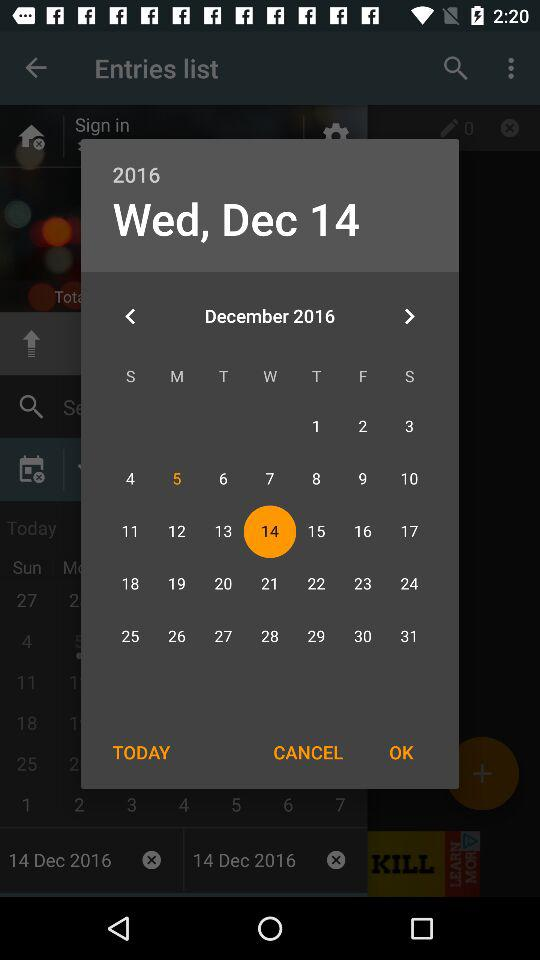Which holiday falls on Wednesday, December 14, 2016?
When the provided information is insufficient, respond with <no answer>. <no answer> 